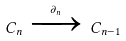<formula> <loc_0><loc_0><loc_500><loc_500>C _ { n } \, \xrightarrow { \partial _ { n } } \, C _ { n - 1 }</formula> 